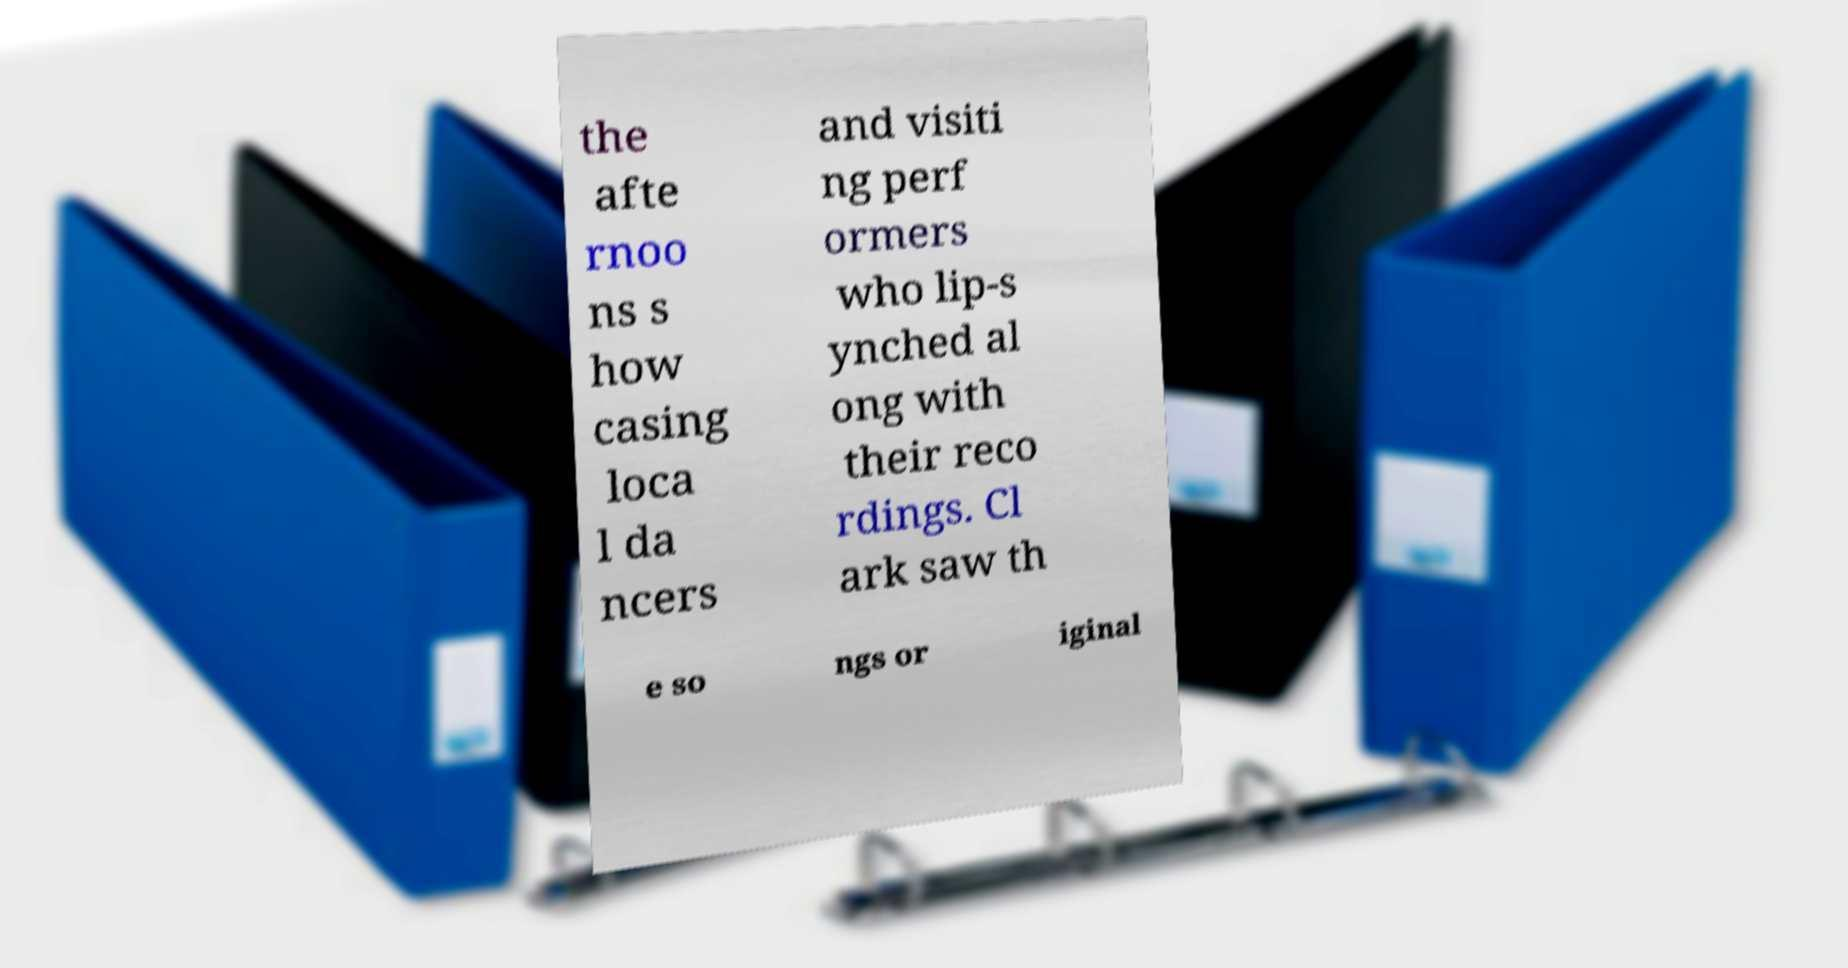I need the written content from this picture converted into text. Can you do that? the afte rnoo ns s how casing loca l da ncers and visiti ng perf ormers who lip-s ynched al ong with their reco rdings. Cl ark saw th e so ngs or iginal 